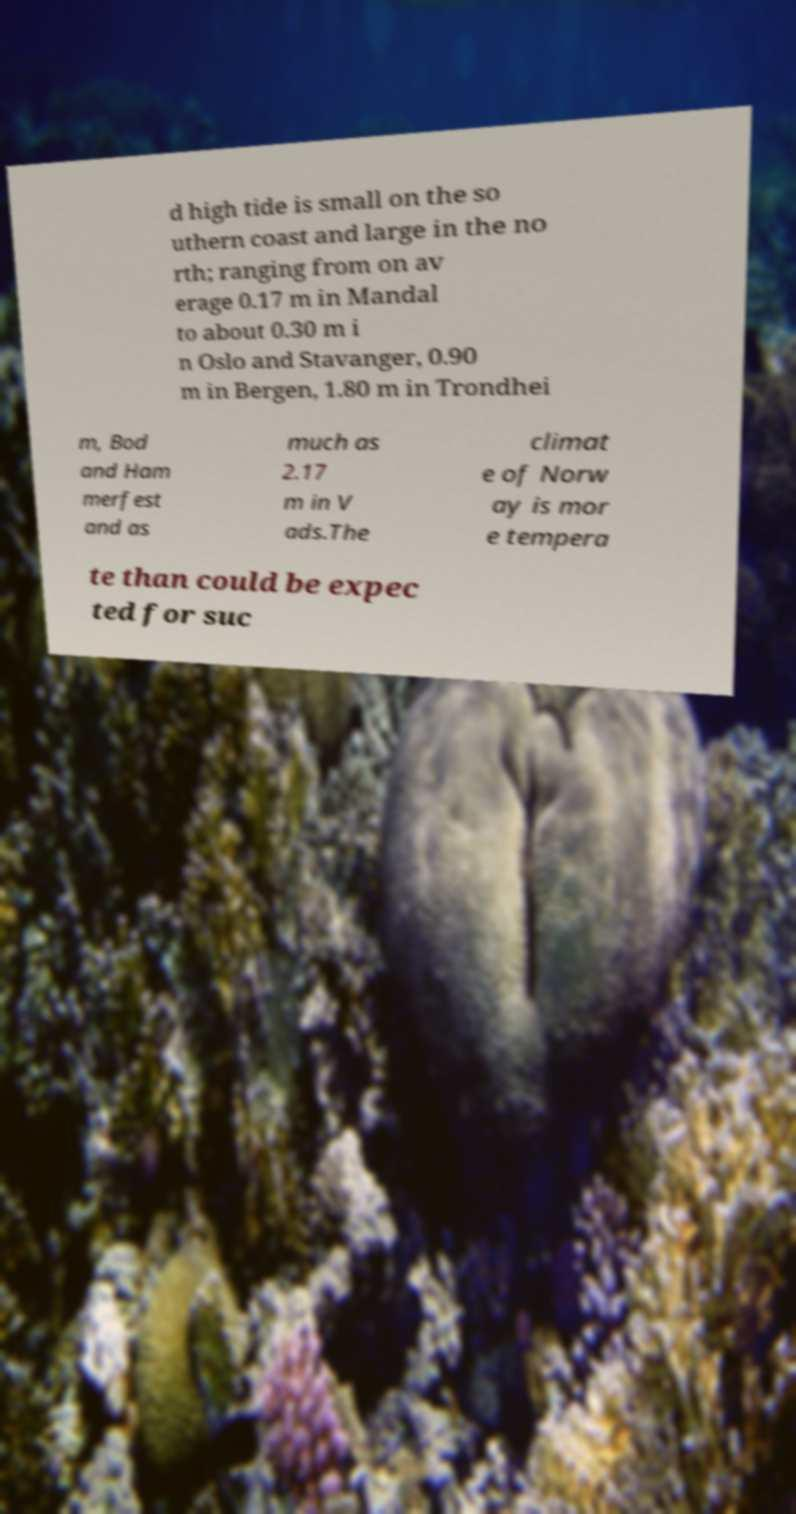Could you extract and type out the text from this image? d high tide is small on the so uthern coast and large in the no rth; ranging from on av erage 0.17 m in Mandal to about 0.30 m i n Oslo and Stavanger, 0.90 m in Bergen, 1.80 m in Trondhei m, Bod and Ham merfest and as much as 2.17 m in V ads.The climat e of Norw ay is mor e tempera te than could be expec ted for suc 